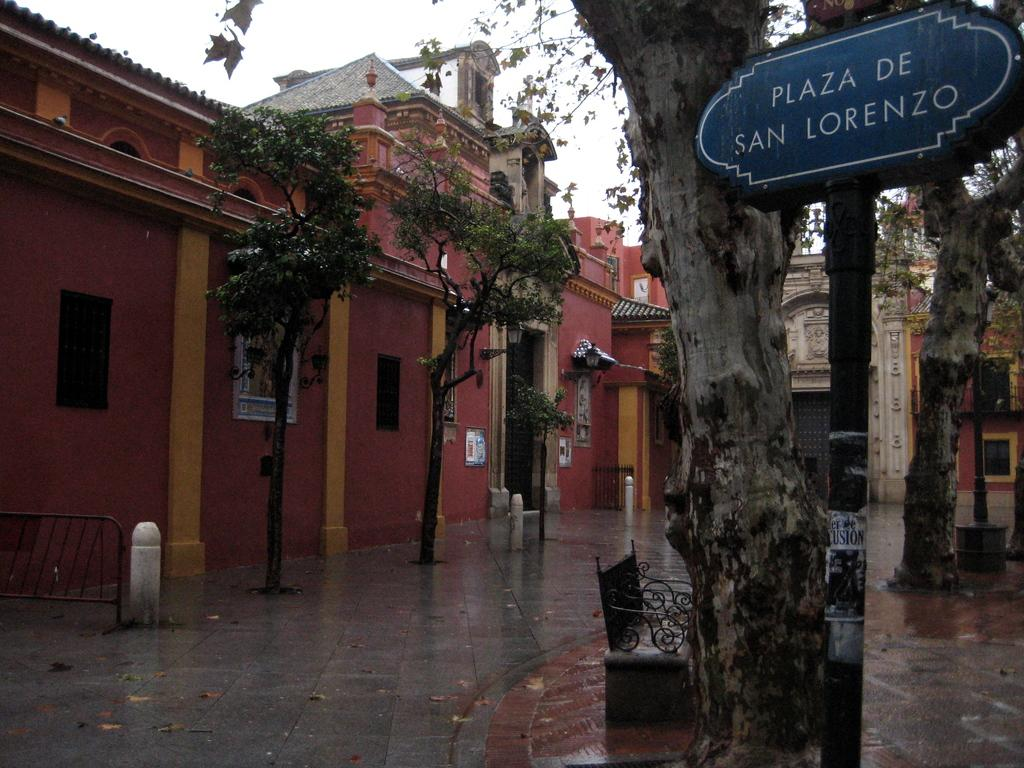Provide a one-sentence caption for the provided image. The Plaza De San Lorenzo sign is to the right of the tree. 